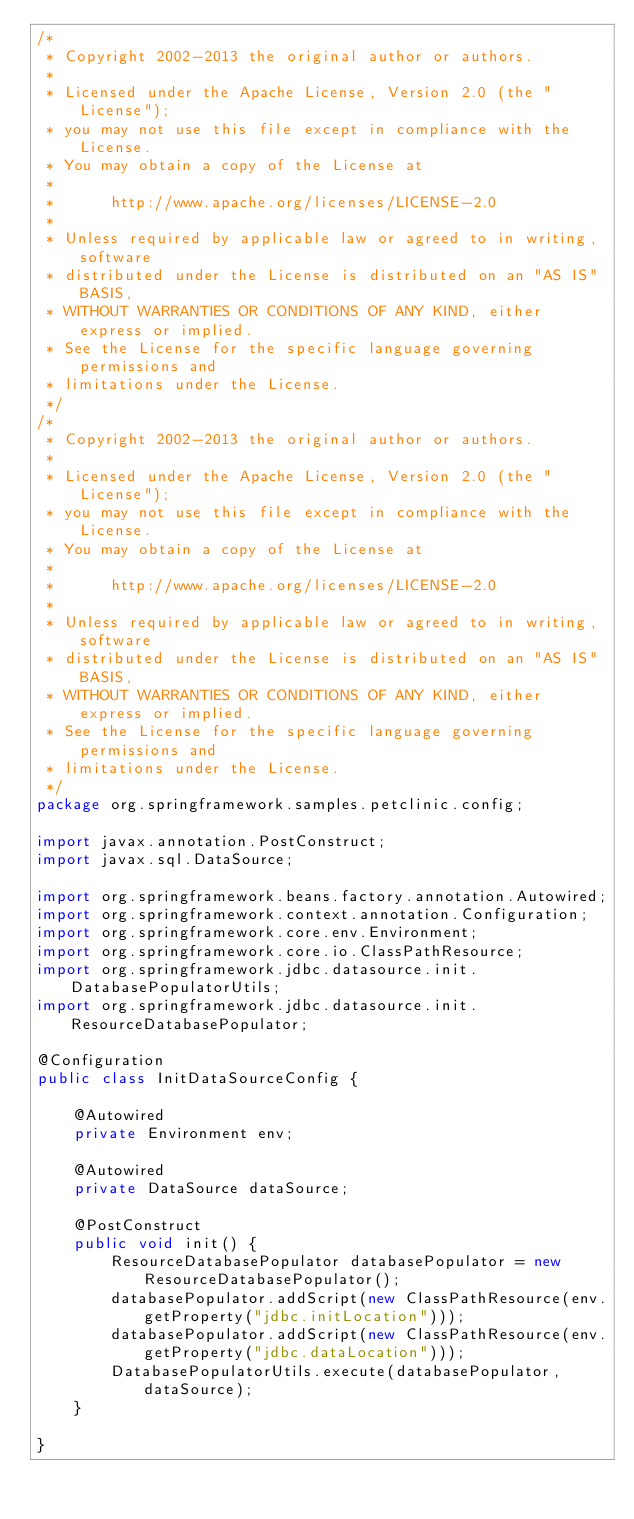Convert code to text. <code><loc_0><loc_0><loc_500><loc_500><_Java_>/*
 * Copyright 2002-2013 the original author or authors.
 *
 * Licensed under the Apache License, Version 2.0 (the "License");
 * you may not use this file except in compliance with the License.
 * You may obtain a copy of the License at
 *
 *      http://www.apache.org/licenses/LICENSE-2.0
 *
 * Unless required by applicable law or agreed to in writing, software
 * distributed under the License is distributed on an "AS IS" BASIS,
 * WITHOUT WARRANTIES OR CONDITIONS OF ANY KIND, either express or implied.
 * See the License for the specific language governing permissions and
 * limitations under the License.
 */
/*
 * Copyright 2002-2013 the original author or authors.
 *
 * Licensed under the Apache License, Version 2.0 (the "License");
 * you may not use this file except in compliance with the License.
 * You may obtain a copy of the License at
 *
 *      http://www.apache.org/licenses/LICENSE-2.0
 *
 * Unless required by applicable law or agreed to in writing, software
 * distributed under the License is distributed on an "AS IS" BASIS,
 * WITHOUT WARRANTIES OR CONDITIONS OF ANY KIND, either express or implied.
 * See the License for the specific language governing permissions and
 * limitations under the License.
 */
package org.springframework.samples.petclinic.config;

import javax.annotation.PostConstruct;
import javax.sql.DataSource;

import org.springframework.beans.factory.annotation.Autowired;
import org.springframework.context.annotation.Configuration;
import org.springframework.core.env.Environment;
import org.springframework.core.io.ClassPathResource;
import org.springframework.jdbc.datasource.init.DatabasePopulatorUtils;
import org.springframework.jdbc.datasource.init.ResourceDatabasePopulator;

@Configuration
public class InitDataSourceConfig {

	@Autowired
	private Environment env;

	@Autowired
	private DataSource dataSource;

	@PostConstruct
	public void init() {
		ResourceDatabasePopulator databasePopulator = new ResourceDatabasePopulator();
		databasePopulator.addScript(new ClassPathResource(env.getProperty("jdbc.initLocation")));
		databasePopulator.addScript(new ClassPathResource(env.getProperty("jdbc.dataLocation")));
		DatabasePopulatorUtils.execute(databasePopulator, dataSource);
	}

}
</code> 